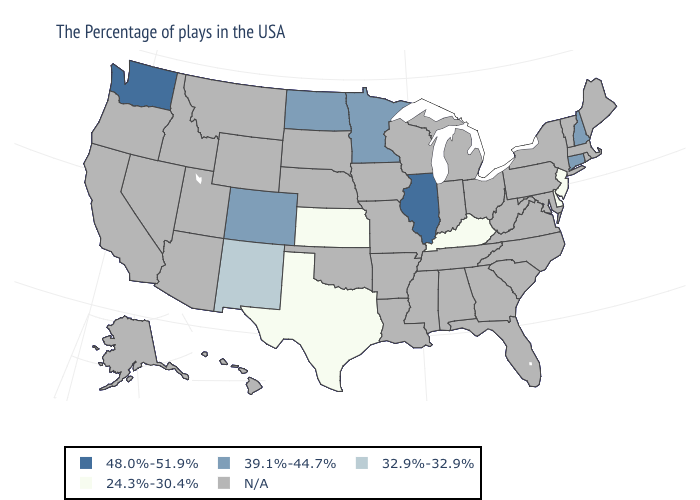Does New Jersey have the lowest value in the USA?
Answer briefly. Yes. What is the lowest value in the Northeast?
Short answer required. 24.3%-30.4%. Name the states that have a value in the range N/A?
Keep it brief. Maine, Massachusetts, Rhode Island, Vermont, New York, Maryland, Pennsylvania, Virginia, North Carolina, South Carolina, West Virginia, Ohio, Florida, Georgia, Michigan, Indiana, Alabama, Tennessee, Wisconsin, Mississippi, Louisiana, Missouri, Arkansas, Iowa, Nebraska, Oklahoma, South Dakota, Wyoming, Utah, Montana, Arizona, Idaho, Nevada, California, Oregon, Alaska, Hawaii. Among the states that border Indiana , does Illinois have the lowest value?
Keep it brief. No. How many symbols are there in the legend?
Give a very brief answer. 5. Name the states that have a value in the range 39.1%-44.7%?
Quick response, please. New Hampshire, Connecticut, Minnesota, North Dakota, Colorado. Name the states that have a value in the range 24.3%-30.4%?
Short answer required. New Jersey, Delaware, Kentucky, Kansas, Texas. What is the highest value in the USA?
Keep it brief. 48.0%-51.9%. What is the value of Alabama?
Give a very brief answer. N/A. What is the lowest value in states that border Wyoming?
Concise answer only. 39.1%-44.7%. Name the states that have a value in the range 39.1%-44.7%?
Answer briefly. New Hampshire, Connecticut, Minnesota, North Dakota, Colorado. Which states hav the highest value in the Northeast?
Quick response, please. New Hampshire, Connecticut. Name the states that have a value in the range 24.3%-30.4%?
Short answer required. New Jersey, Delaware, Kentucky, Kansas, Texas. What is the value of South Dakota?
Give a very brief answer. N/A. 